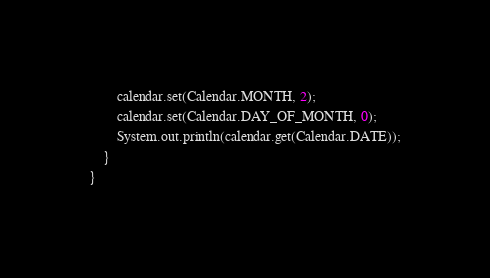<code> <loc_0><loc_0><loc_500><loc_500><_Java_>		calendar.set(Calendar.MONTH, 2);
		calendar.set(Calendar.DAY_OF_MONTH, 0);
		System.out.println(calendar.get(Calendar.DATE));
	}
}
</code> 